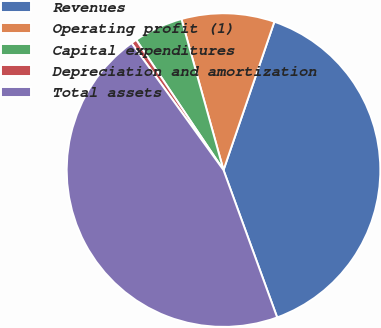Convert chart to OTSL. <chart><loc_0><loc_0><loc_500><loc_500><pie_chart><fcel>Revenues<fcel>Operating profit (1)<fcel>Capital expenditures<fcel>Depreciation and amortization<fcel>Total assets<nl><fcel>39.19%<fcel>9.58%<fcel>5.08%<fcel>0.57%<fcel>45.59%<nl></chart> 